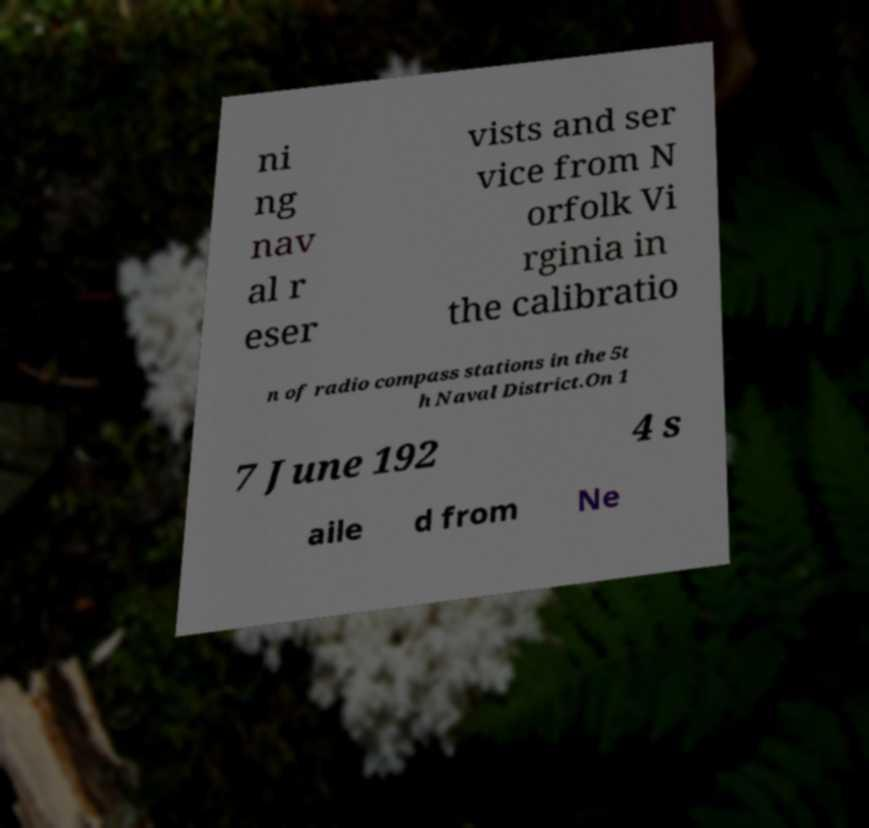There's text embedded in this image that I need extracted. Can you transcribe it verbatim? ni ng nav al r eser vists and ser vice from N orfolk Vi rginia in the calibratio n of radio compass stations in the 5t h Naval District.On 1 7 June 192 4 s aile d from Ne 